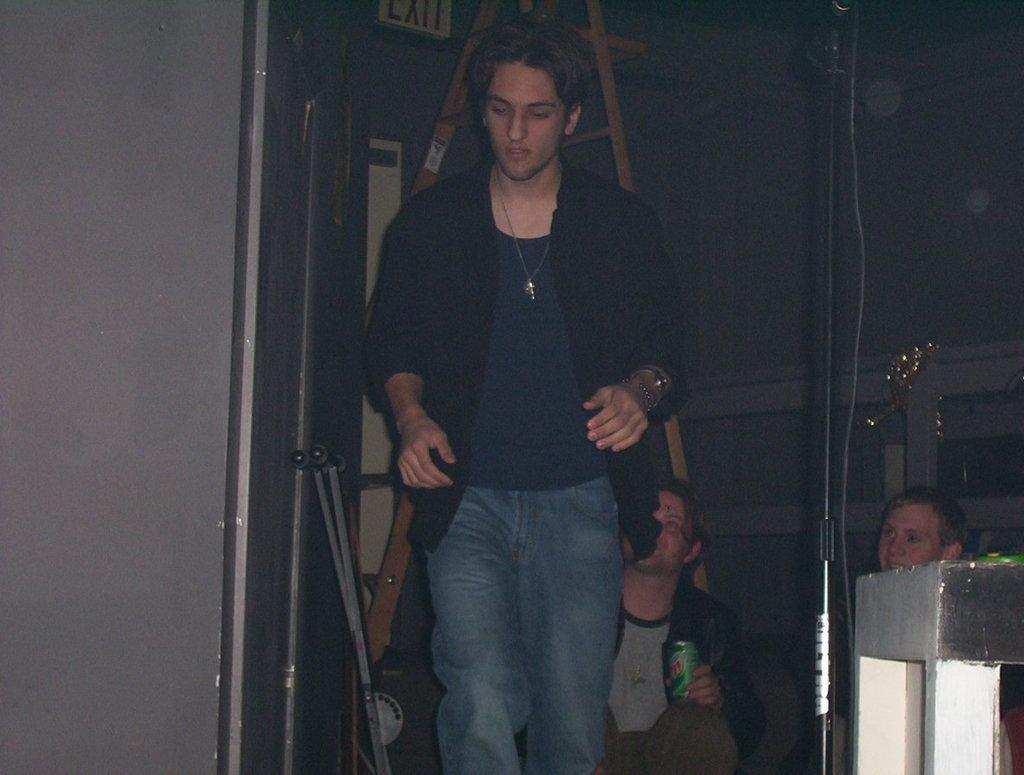Who is the main subject in the center of the image? There is a man in the center of the image. What can be seen on the right side of the image? There are people on the right side of the image. What structure is present in the image? There is a stand in the image. What architectural features are visible in the background of the image? There is a door, a ladder, and a wall in the background of the image. What object is present in the image that is typically used for holding or storing items? There is a tin in the image. What type of seed is being planted by the man in the image? There is no seed or planting activity depicted in the image; the man is simply standing in the center. 